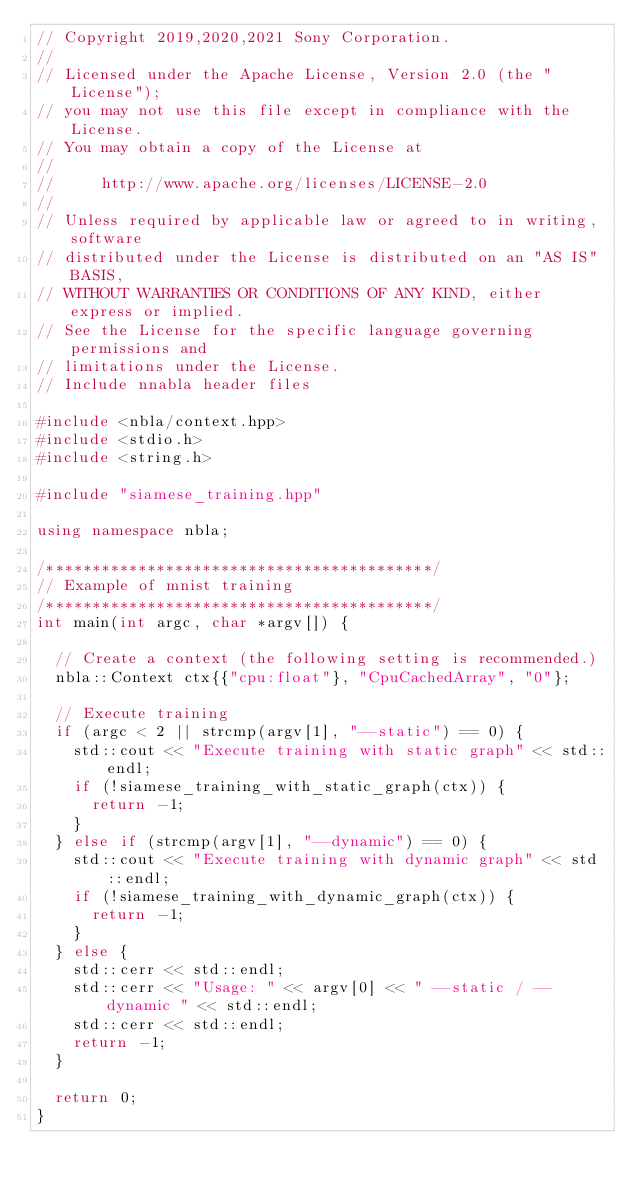<code> <loc_0><loc_0><loc_500><loc_500><_C++_>// Copyright 2019,2020,2021 Sony Corporation.
//
// Licensed under the Apache License, Version 2.0 (the "License");
// you may not use this file except in compliance with the License.
// You may obtain a copy of the License at
//
//     http://www.apache.org/licenses/LICENSE-2.0
//
// Unless required by applicable law or agreed to in writing, software
// distributed under the License is distributed on an "AS IS" BASIS,
// WITHOUT WARRANTIES OR CONDITIONS OF ANY KIND, either express or implied.
// See the License for the specific language governing permissions and
// limitations under the License.
// Include nnabla header files

#include <nbla/context.hpp>
#include <stdio.h>
#include <string.h>

#include "siamese_training.hpp"

using namespace nbla;

/******************************************/
// Example of mnist training
/******************************************/
int main(int argc, char *argv[]) {

  // Create a context (the following setting is recommended.)
  nbla::Context ctx{{"cpu:float"}, "CpuCachedArray", "0"};

  // Execute training
  if (argc < 2 || strcmp(argv[1], "--static") == 0) {
    std::cout << "Execute training with static graph" << std::endl;
    if (!siamese_training_with_static_graph(ctx)) {
      return -1;
    }
  } else if (strcmp(argv[1], "--dynamic") == 0) {
    std::cout << "Execute training with dynamic graph" << std::endl;
    if (!siamese_training_with_dynamic_graph(ctx)) {
      return -1;
    }
  } else {
    std::cerr << std::endl;
    std::cerr << "Usage: " << argv[0] << " --static / --dynamic " << std::endl;
    std::cerr << std::endl;
    return -1;
  }

  return 0;
}
</code> 